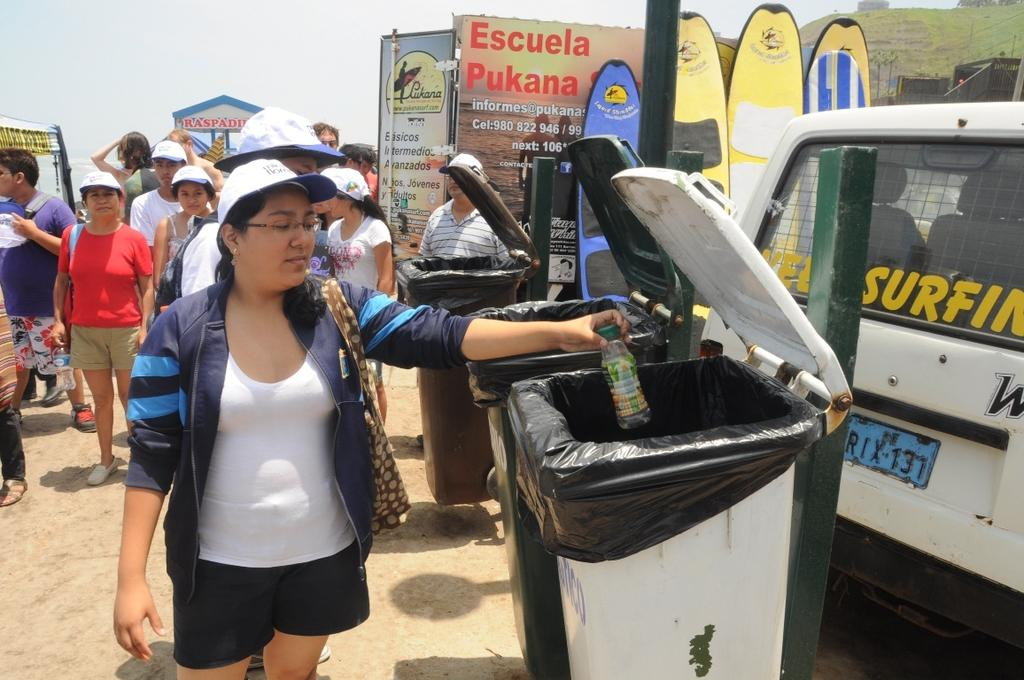<image>
Present a compact description of the photo's key features. Person throwing away garbage inside a bin next to a vehicle that says SURFING on it. 